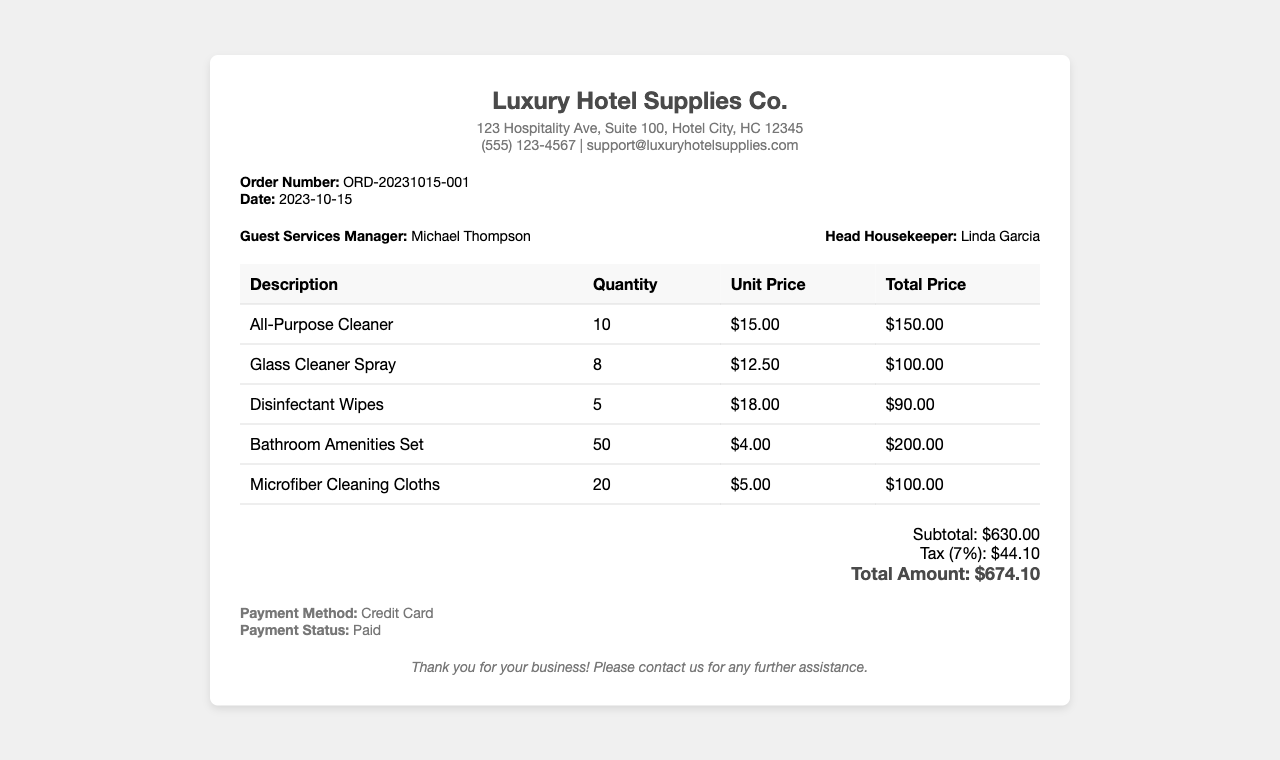What is the order number? The order number is a unique identifier for the purchase, found in the document.
Answer: ORD-20231015-001 Who is the Guest Services Manager? The name of the Guest Services Manager is listed under the staff information section of the document.
Answer: Michael Thompson What is the total amount due? The total amount is the sum of the subtotal and tax provided in the document.
Answer: $674.10 How many Bathroom Amenities Sets were ordered? The quantity of Bathroom Amenities Sets is specified in the itemized list in the document.
Answer: 50 What is the tax percentage applied? The tax percentage is related to the subtotal and mentioned in the totals section of the document.
Answer: 7% What is the unit price of Disinfectant Wipes? The unit price is indicated in the itemized cost on the receipt.
Answer: $18.00 What payment method was used? The payment method is clearly stated in the payment information section of the receipt.
Answer: Credit Card What is the subtotal amount? The subtotal is the sum of all items before tax, which is stated in the totals section.
Answer: $630.00 Who is the Head Housekeeper? The name of the Head Housekeeper is provided in the staff information section of the document.
Answer: Linda Garcia 